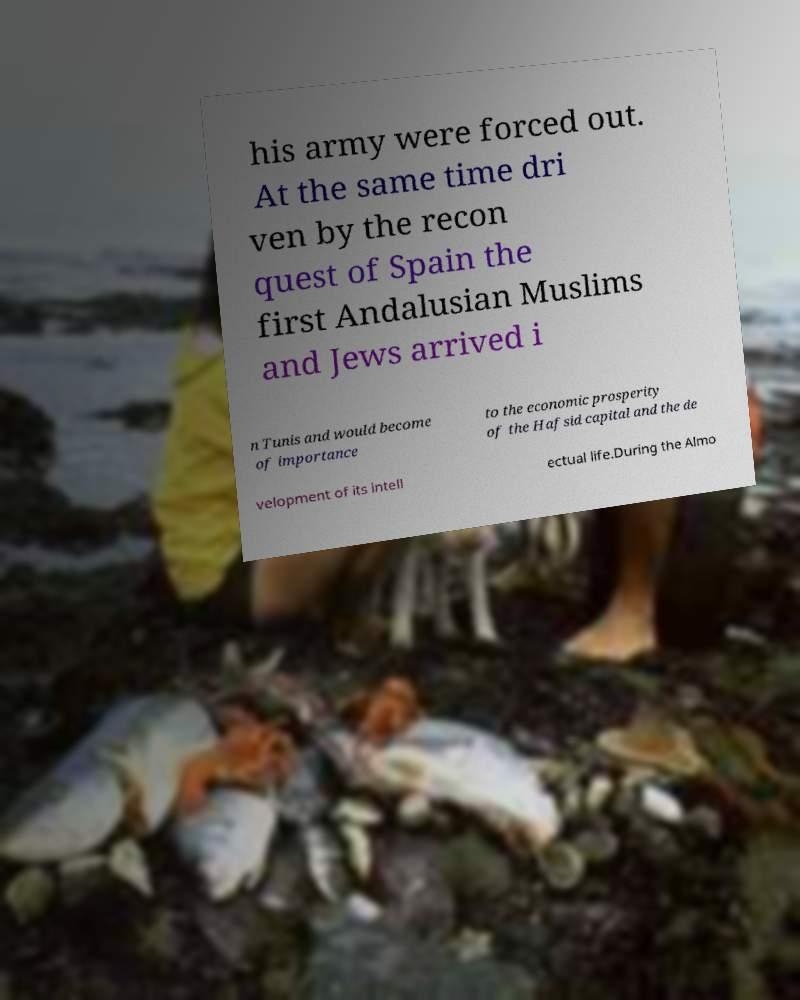There's text embedded in this image that I need extracted. Can you transcribe it verbatim? his army were forced out. At the same time dri ven by the recon quest of Spain the first Andalusian Muslims and Jews arrived i n Tunis and would become of importance to the economic prosperity of the Hafsid capital and the de velopment of its intell ectual life.During the Almo 